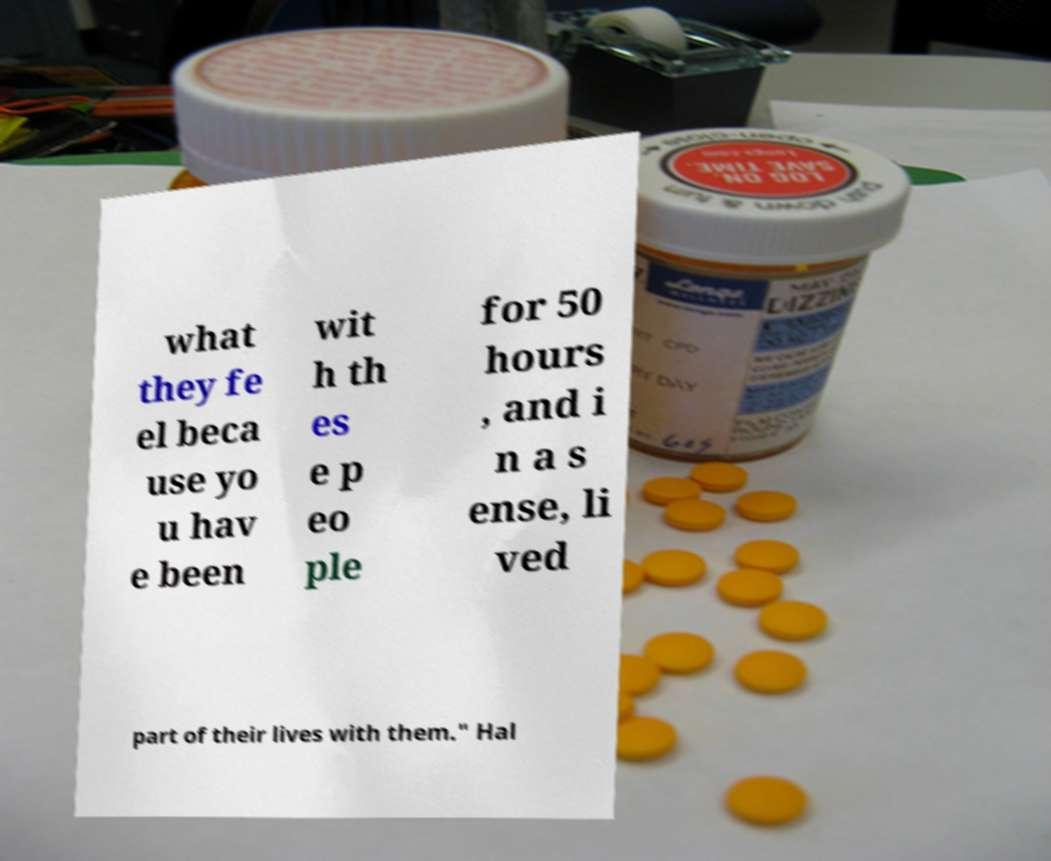I need the written content from this picture converted into text. Can you do that? what they fe el beca use yo u hav e been wit h th es e p eo ple for 50 hours , and i n a s ense, li ved part of their lives with them." Hal 